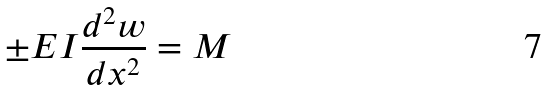<formula> <loc_0><loc_0><loc_500><loc_500>\pm E I \frac { d ^ { 2 } w } { d x ^ { 2 } } = M</formula> 